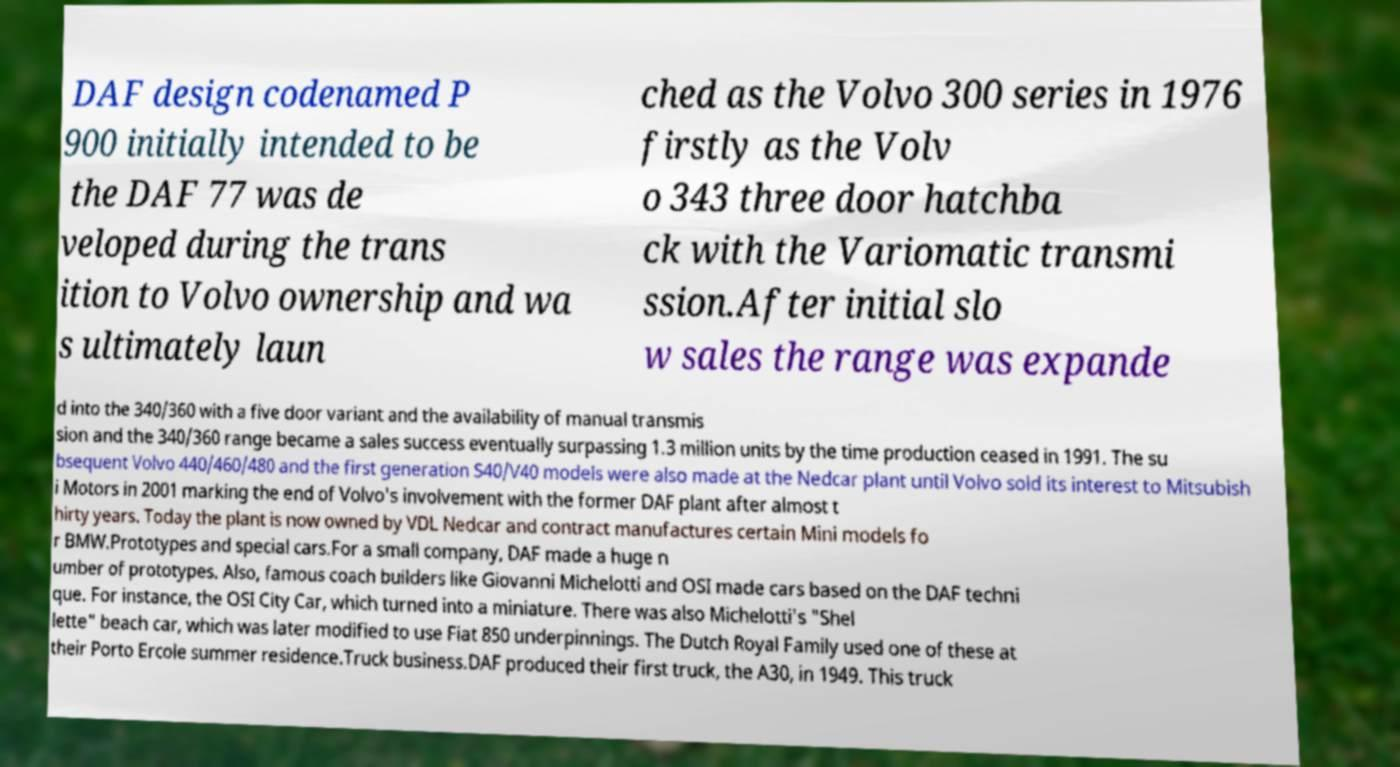Can you read and provide the text displayed in the image?This photo seems to have some interesting text. Can you extract and type it out for me? DAF design codenamed P 900 initially intended to be the DAF 77 was de veloped during the trans ition to Volvo ownership and wa s ultimately laun ched as the Volvo 300 series in 1976 firstly as the Volv o 343 three door hatchba ck with the Variomatic transmi ssion.After initial slo w sales the range was expande d into the 340/360 with a five door variant and the availability of manual transmis sion and the 340/360 range became a sales success eventually surpassing 1.3 million units by the time production ceased in 1991. The su bsequent Volvo 440/460/480 and the first generation S40/V40 models were also made at the Nedcar plant until Volvo sold its interest to Mitsubish i Motors in 2001 marking the end of Volvo's involvement with the former DAF plant after almost t hirty years. Today the plant is now owned by VDL Nedcar and contract manufactures certain Mini models fo r BMW.Prototypes and special cars.For a small company, DAF made a huge n umber of prototypes. Also, famous coach builders like Giovanni Michelotti and OSI made cars based on the DAF techni que. For instance, the OSI City Car, which turned into a miniature. There was also Michelotti's "Shel lette" beach car, which was later modified to use Fiat 850 underpinnings. The Dutch Royal Family used one of these at their Porto Ercole summer residence.Truck business.DAF produced their first truck, the A30, in 1949. This truck 